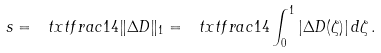<formula> <loc_0><loc_0><loc_500><loc_500>s = \ t x t f r a c 1 4 \| \Delta D \| _ { 1 } = \ t x t f r a c 1 4 \int _ { 0 } ^ { 1 } | \Delta D ( \zeta ) | \, d \zeta \, .</formula> 